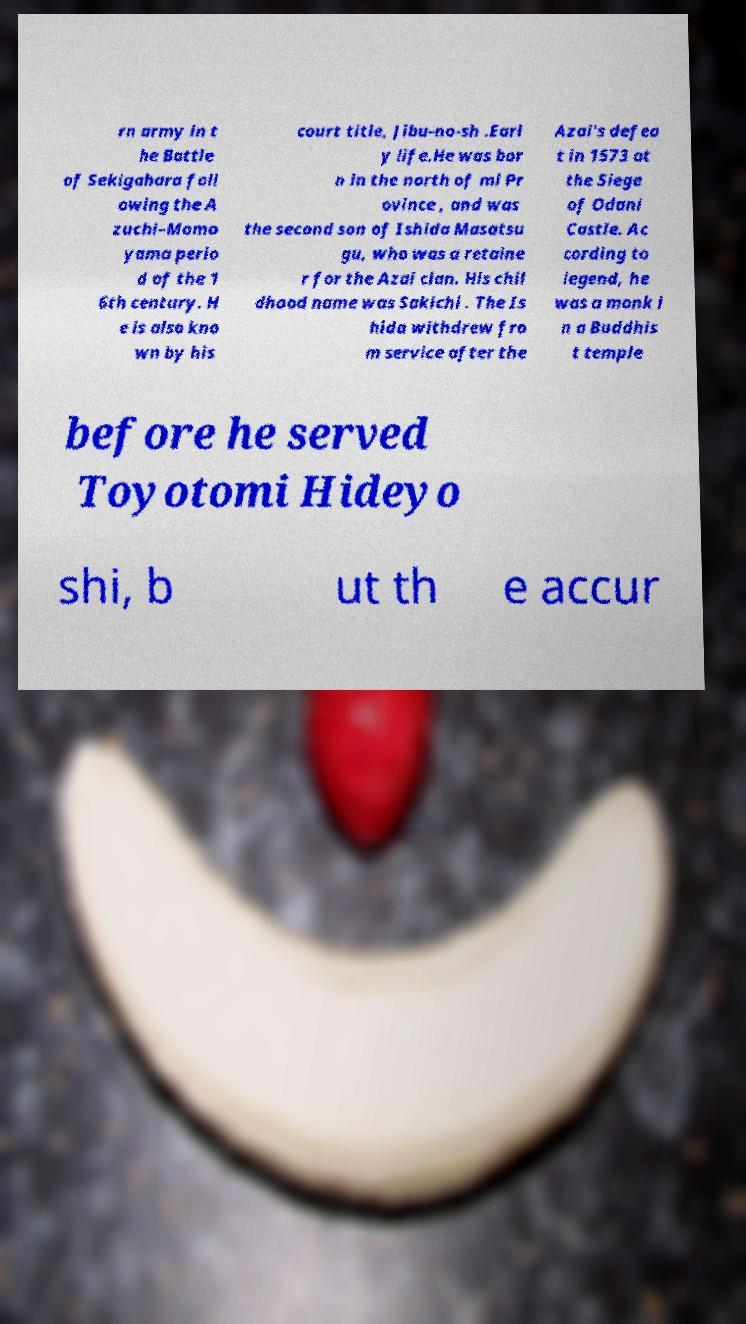Please identify and transcribe the text found in this image. rn army in t he Battle of Sekigahara foll owing the A zuchi–Momo yama perio d of the 1 6th century. H e is also kno wn by his court title, Jibu-no-sh .Earl y life.He was bor n in the north of mi Pr ovince , and was the second son of Ishida Masatsu gu, who was a retaine r for the Azai clan. His chil dhood name was Sakichi . The Is hida withdrew fro m service after the Azai's defea t in 1573 at the Siege of Odani Castle. Ac cording to legend, he was a monk i n a Buddhis t temple before he served Toyotomi Hideyo shi, b ut th e accur 